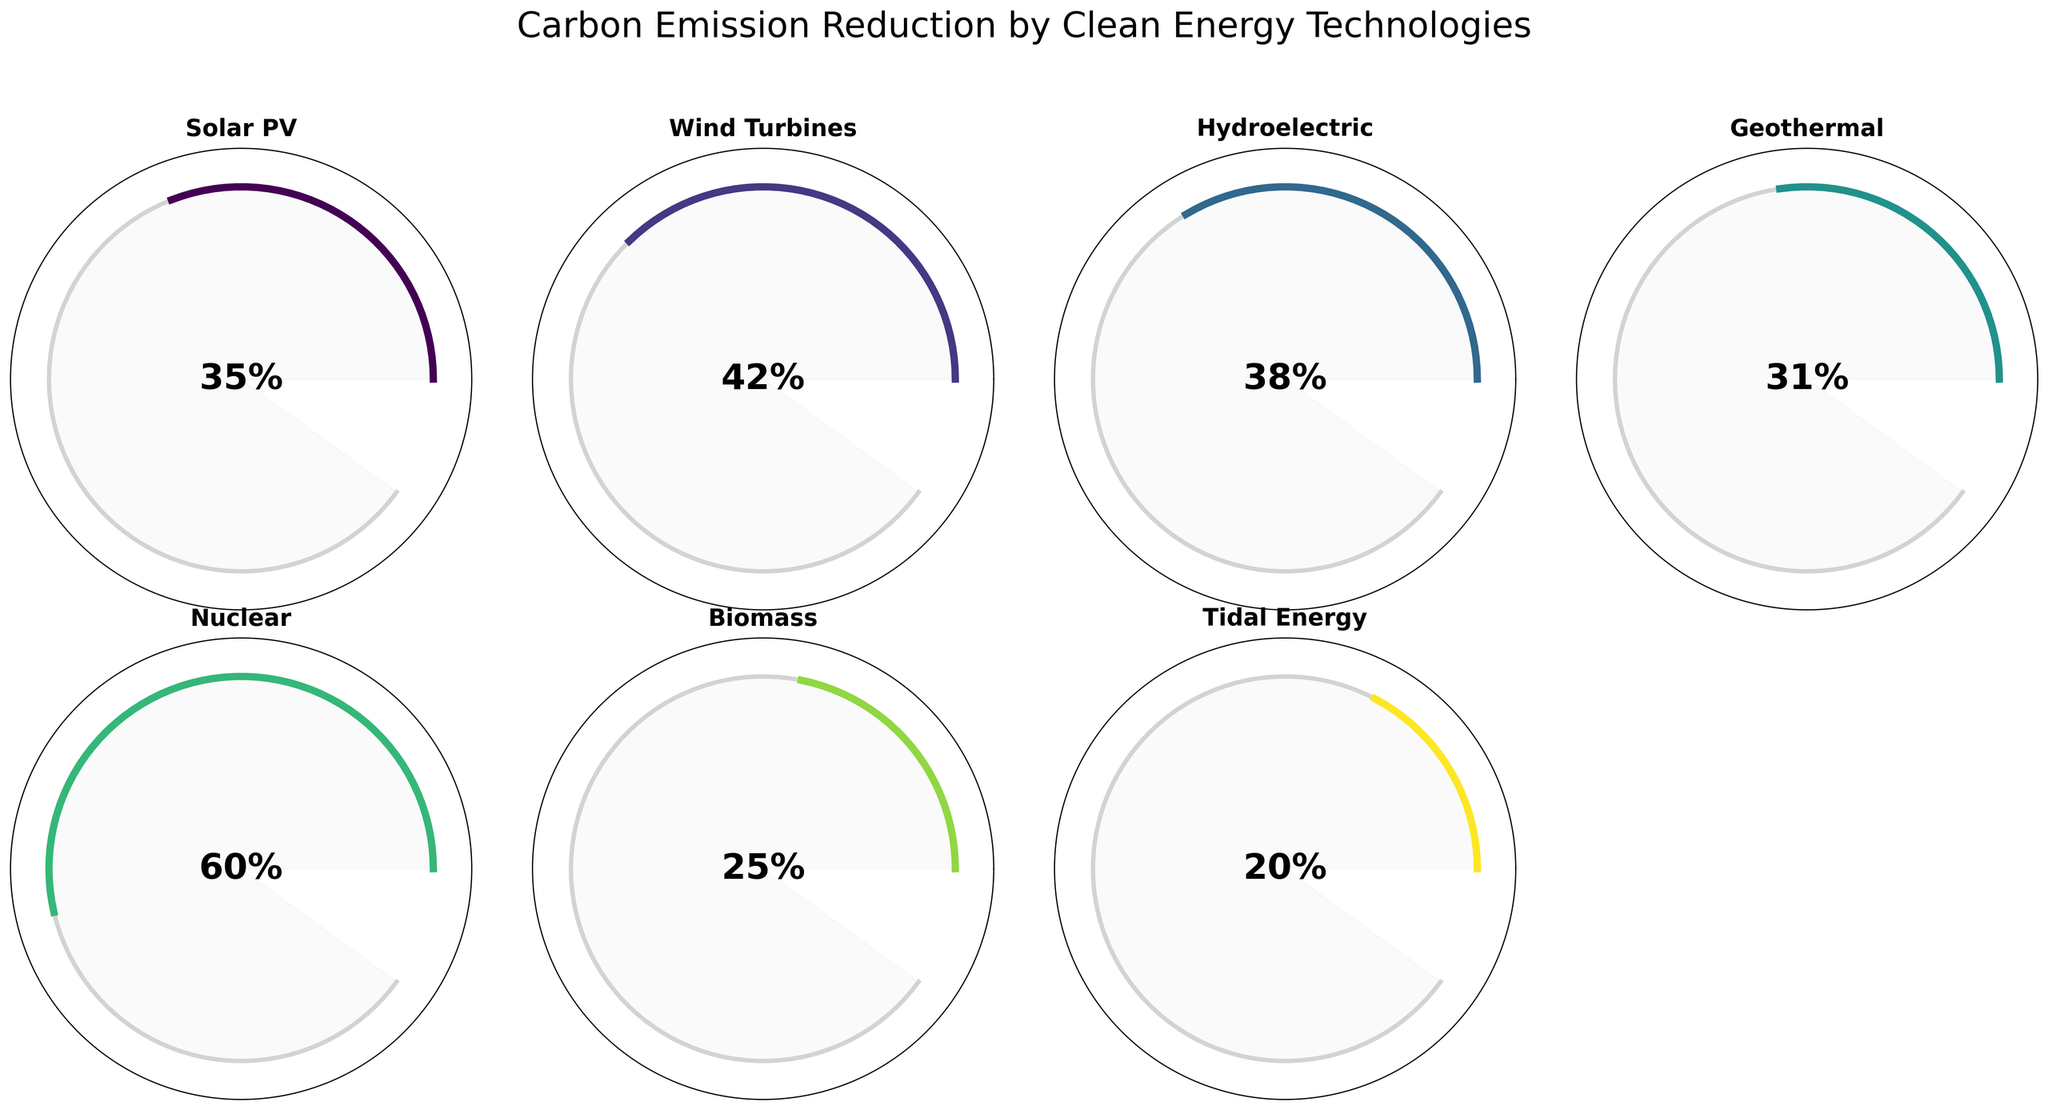what is the title of the figure? The title is displayed at the top of the figure in a larger font. It reads "Carbon Emission Reduction by Clean Energy Technologies".
Answer: Carbon Emission Reduction by Clean Energy Technologies Which clean energy technology achieves the highest carbon emission reduction? By looking at the gauge charts, we can see that the "Nuclear" gauge has the highest percentage indicated (60%).
Answer: Nuclear How much higher is the carbon reduction percentage of Wind Turbines compared to Biomass? The carbon reduction percentage for Wind Turbines is 42%, and for Biomass, it's 25%. The difference is 42% - 25%.
Answer: 17% Which technologies have a carbon reduction percentage greater than 30%? By analyzing the gauge charts, we can see the percentages for Solar PV (35%), Wind Turbines (42%), Hydroelectric (38%), and Nuclear (60%) are all greater than 30%.
Answer: Solar PV, Wind Turbines, Hydroelectric, Nuclear What is the average carbon reduction percentage of Solar PV, Wind Turbines, and Geothermal? The percentages are: Solar PV - 35%, Wind Turbines - 42%, Geothermal - 31%. The average is calculated as (35 + 42 + 31) / 3.
Answer: 36% Which technology has the lowest carbon reduction percentage and what is it? The lowest carbon reduction percentage is shown in the figure for Tidal Energy with 20%.
Answer: Tidal Energy, 20% Is the carbon reduction percentage of Hydroelectric closer to that of Solar PV or Geothermal? Hydroelectric has a percentage of 38%, Solar PV has 35%, and Geothermal has 31%. Since 38 is closer to 35 than to 31, it's closer to Solar PV.
Answer: Solar PV How many technologies achieve a carbon reduction percentage above 20% but below 40%? By looking at the gauges, Solar PV (35%), Hydroelectric (38%), and Geothermal (31%) fall in this range. This makes a total of three technologies.
Answer: 3 Combining the percentages of Wind Turbines and Biomass, what would the total carbon reduction percentage be? Wind Turbines have a reduction of 42% and Biomass has 25%. Adding these together gives us 42 + 25.
Answer: 67% Which has a higher carbon reduction percentage: Tidal Energy plus Biomass or just Nuclear alone? Tidal Energy has 20%, Biomass has 25%, combined they are 20% + 25% = 45%. Nuclear alone is 60%, which is higher.
Answer: Nuclear alone 